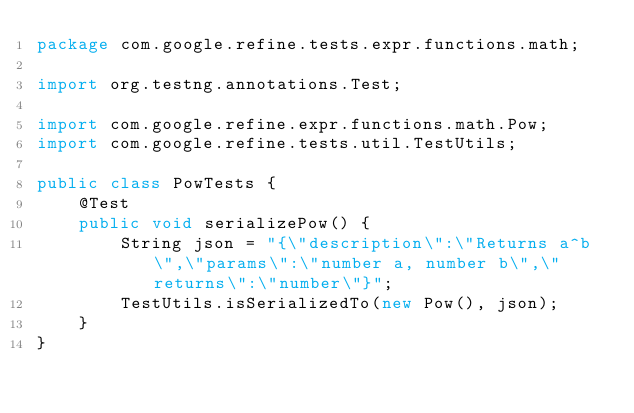<code> <loc_0><loc_0><loc_500><loc_500><_Java_>package com.google.refine.tests.expr.functions.math;

import org.testng.annotations.Test;

import com.google.refine.expr.functions.math.Pow;
import com.google.refine.tests.util.TestUtils;

public class PowTests {
    @Test
    public void serializePow() {
        String json = "{\"description\":\"Returns a^b\",\"params\":\"number a, number b\",\"returns\":\"number\"}";
        TestUtils.isSerializedTo(new Pow(), json);
    }
}

</code> 